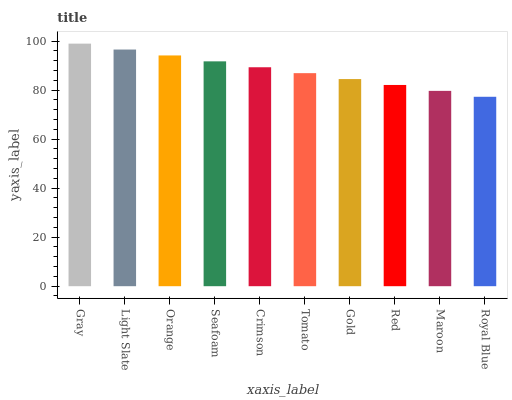Is Royal Blue the minimum?
Answer yes or no. Yes. Is Gray the maximum?
Answer yes or no. Yes. Is Light Slate the minimum?
Answer yes or no. No. Is Light Slate the maximum?
Answer yes or no. No. Is Gray greater than Light Slate?
Answer yes or no. Yes. Is Light Slate less than Gray?
Answer yes or no. Yes. Is Light Slate greater than Gray?
Answer yes or no. No. Is Gray less than Light Slate?
Answer yes or no. No. Is Crimson the high median?
Answer yes or no. Yes. Is Tomato the low median?
Answer yes or no. Yes. Is Seafoam the high median?
Answer yes or no. No. Is Gray the low median?
Answer yes or no. No. 